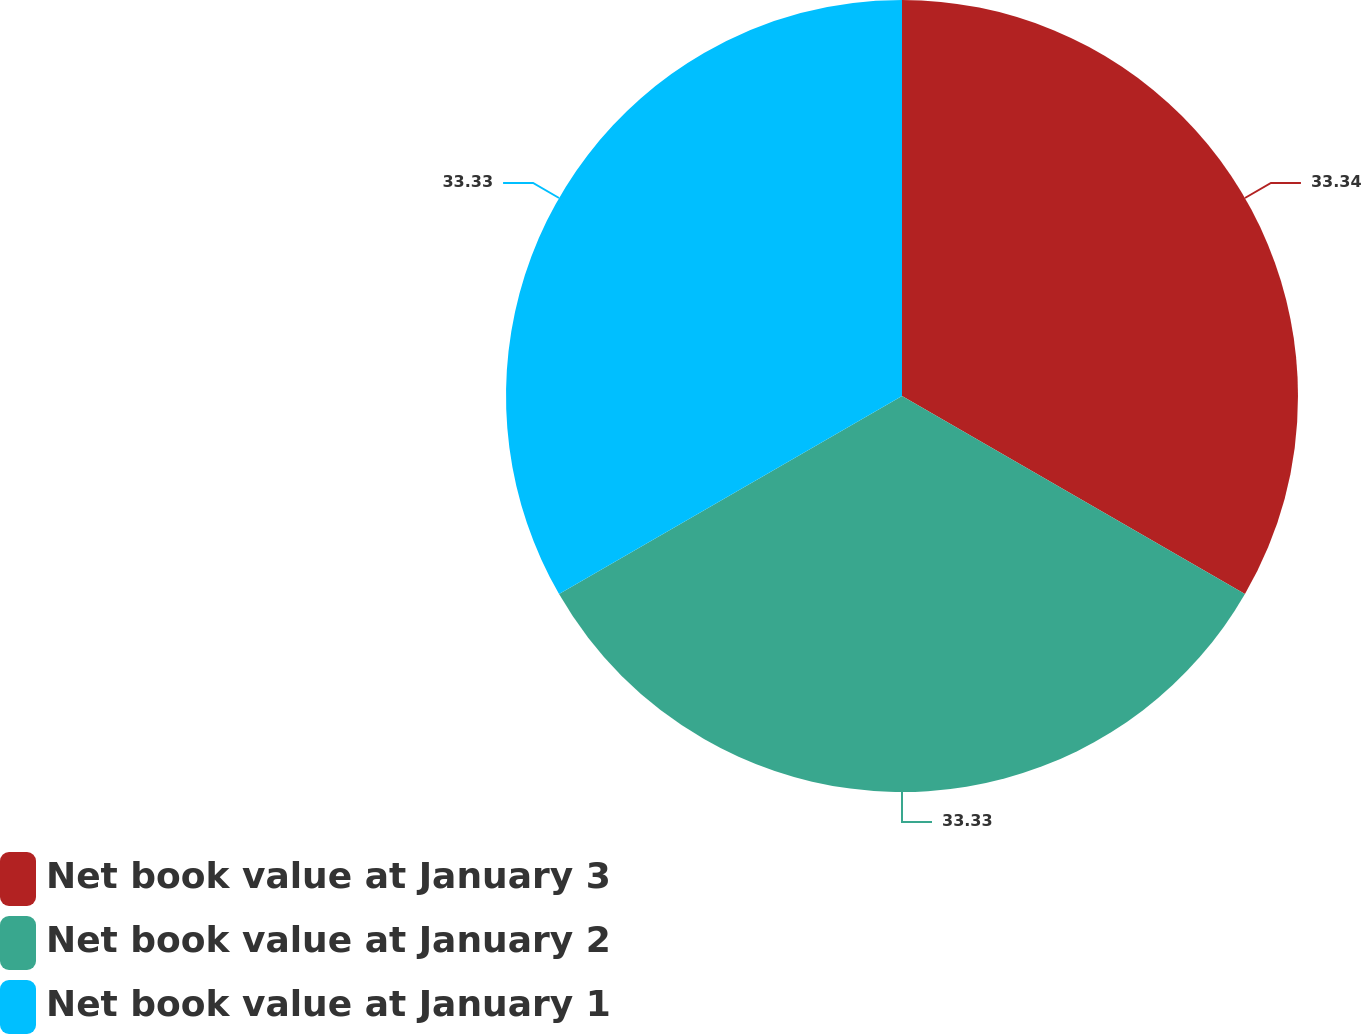Convert chart to OTSL. <chart><loc_0><loc_0><loc_500><loc_500><pie_chart><fcel>Net book value at January 3<fcel>Net book value at January 2<fcel>Net book value at January 1<nl><fcel>33.33%<fcel>33.33%<fcel>33.33%<nl></chart> 